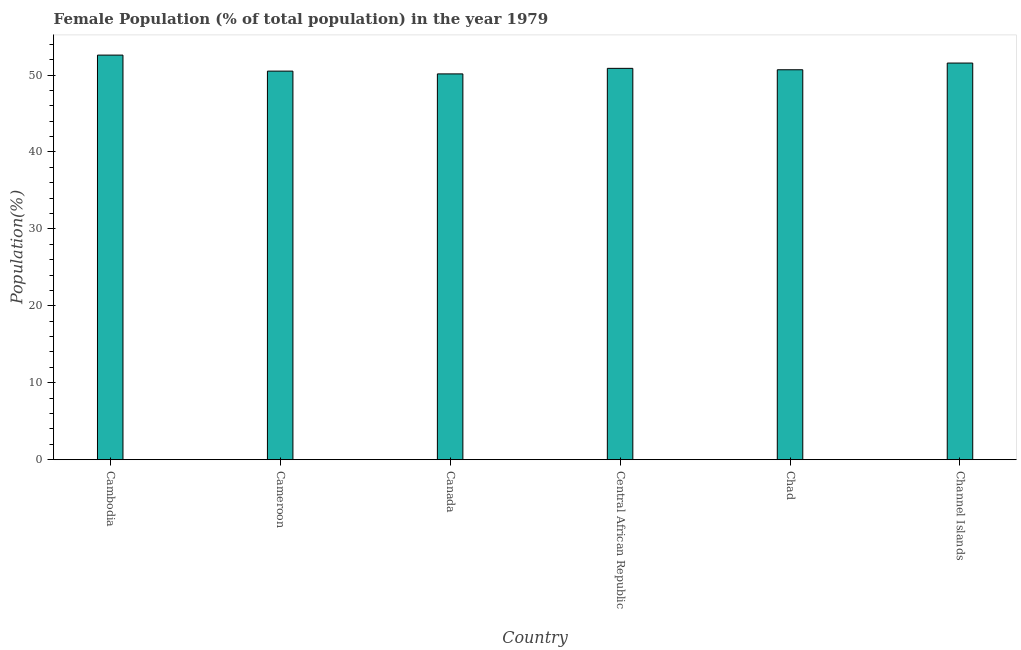Does the graph contain any zero values?
Offer a very short reply. No. Does the graph contain grids?
Your response must be concise. No. What is the title of the graph?
Give a very brief answer. Female Population (% of total population) in the year 1979. What is the label or title of the Y-axis?
Your response must be concise. Population(%). What is the female population in Channel Islands?
Your answer should be very brief. 51.56. Across all countries, what is the maximum female population?
Offer a very short reply. 52.59. Across all countries, what is the minimum female population?
Offer a terse response. 50.15. In which country was the female population maximum?
Provide a succinct answer. Cambodia. In which country was the female population minimum?
Make the answer very short. Canada. What is the sum of the female population?
Make the answer very short. 306.37. What is the difference between the female population in Chad and Channel Islands?
Keep it short and to the point. -0.87. What is the average female population per country?
Your answer should be compact. 51.06. What is the median female population?
Ensure brevity in your answer.  50.78. Is the female population in Cameroon less than that in Central African Republic?
Provide a short and direct response. Yes. Is the difference between the female population in Cameroon and Channel Islands greater than the difference between any two countries?
Offer a very short reply. No. What is the difference between the highest and the second highest female population?
Offer a very short reply. 1.03. Is the sum of the female population in Cameroon and Chad greater than the maximum female population across all countries?
Provide a short and direct response. Yes. What is the difference between the highest and the lowest female population?
Provide a short and direct response. 2.44. In how many countries, is the female population greater than the average female population taken over all countries?
Your response must be concise. 2. How many bars are there?
Your response must be concise. 6. Are the values on the major ticks of Y-axis written in scientific E-notation?
Your response must be concise. No. What is the Population(%) in Cambodia?
Provide a succinct answer. 52.59. What is the Population(%) of Cameroon?
Your response must be concise. 50.51. What is the Population(%) of Canada?
Offer a terse response. 50.15. What is the Population(%) in Central African Republic?
Offer a terse response. 50.87. What is the Population(%) of Chad?
Keep it short and to the point. 50.69. What is the Population(%) in Channel Islands?
Offer a terse response. 51.56. What is the difference between the Population(%) in Cambodia and Cameroon?
Give a very brief answer. 2.08. What is the difference between the Population(%) in Cambodia and Canada?
Offer a terse response. 2.44. What is the difference between the Population(%) in Cambodia and Central African Republic?
Your response must be concise. 1.72. What is the difference between the Population(%) in Cambodia and Chad?
Offer a very short reply. 1.9. What is the difference between the Population(%) in Cambodia and Channel Islands?
Your response must be concise. 1.03. What is the difference between the Population(%) in Cameroon and Canada?
Ensure brevity in your answer.  0.36. What is the difference between the Population(%) in Cameroon and Central African Republic?
Make the answer very short. -0.36. What is the difference between the Population(%) in Cameroon and Chad?
Keep it short and to the point. -0.18. What is the difference between the Population(%) in Cameroon and Channel Islands?
Your answer should be compact. -1.05. What is the difference between the Population(%) in Canada and Central African Republic?
Ensure brevity in your answer.  -0.72. What is the difference between the Population(%) in Canada and Chad?
Keep it short and to the point. -0.54. What is the difference between the Population(%) in Canada and Channel Islands?
Provide a succinct answer. -1.41. What is the difference between the Population(%) in Central African Republic and Chad?
Offer a terse response. 0.18. What is the difference between the Population(%) in Central African Republic and Channel Islands?
Ensure brevity in your answer.  -0.69. What is the difference between the Population(%) in Chad and Channel Islands?
Keep it short and to the point. -0.87. What is the ratio of the Population(%) in Cambodia to that in Cameroon?
Offer a very short reply. 1.04. What is the ratio of the Population(%) in Cambodia to that in Canada?
Provide a succinct answer. 1.05. What is the ratio of the Population(%) in Cambodia to that in Central African Republic?
Your answer should be very brief. 1.03. What is the ratio of the Population(%) in Cambodia to that in Chad?
Provide a succinct answer. 1.04. What is the ratio of the Population(%) in Cambodia to that in Channel Islands?
Provide a short and direct response. 1.02. What is the ratio of the Population(%) in Canada to that in Chad?
Provide a succinct answer. 0.99. What is the ratio of the Population(%) in Central African Republic to that in Chad?
Give a very brief answer. 1. What is the ratio of the Population(%) in Central African Republic to that in Channel Islands?
Your answer should be very brief. 0.99. What is the ratio of the Population(%) in Chad to that in Channel Islands?
Your response must be concise. 0.98. 